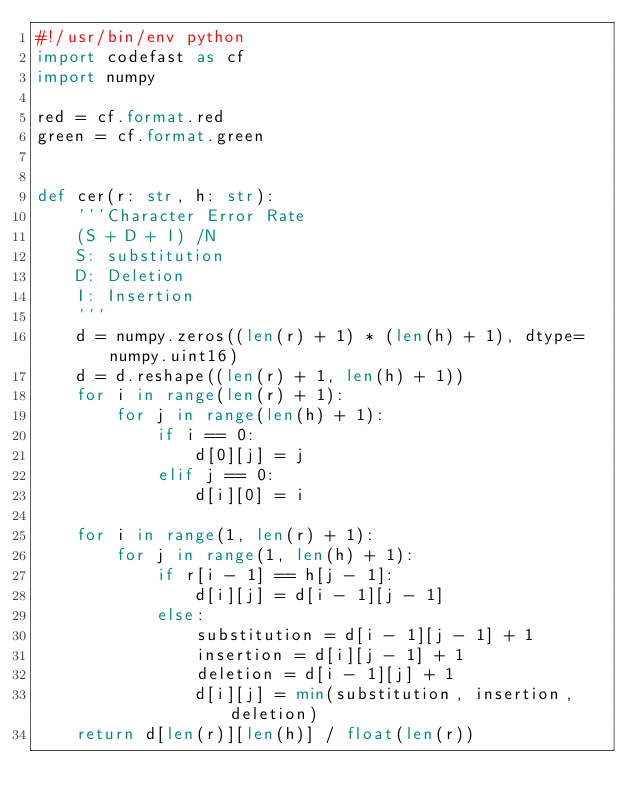<code> <loc_0><loc_0><loc_500><loc_500><_Python_>#!/usr/bin/env python
import codefast as cf
import numpy

red = cf.format.red
green = cf.format.green


def cer(r: str, h: str):
    '''Character Error Rate
    (S + D + I) /N 
    S: substitution
    D: Deletion
    I: Insertion
    '''
    d = numpy.zeros((len(r) + 1) * (len(h) + 1), dtype=numpy.uint16)
    d = d.reshape((len(r) + 1, len(h) + 1))
    for i in range(len(r) + 1):
        for j in range(len(h) + 1):
            if i == 0:
                d[0][j] = j
            elif j == 0:
                d[i][0] = i
                
    for i in range(1, len(r) + 1):
        for j in range(1, len(h) + 1):
            if r[i - 1] == h[j - 1]:
                d[i][j] = d[i - 1][j - 1]
            else:
                substitution = d[i - 1][j - 1] + 1
                insertion = d[i][j - 1] + 1
                deletion = d[i - 1][j] + 1
                d[i][j] = min(substitution, insertion, deletion)
    return d[len(r)][len(h)] / float(len(r))
</code> 